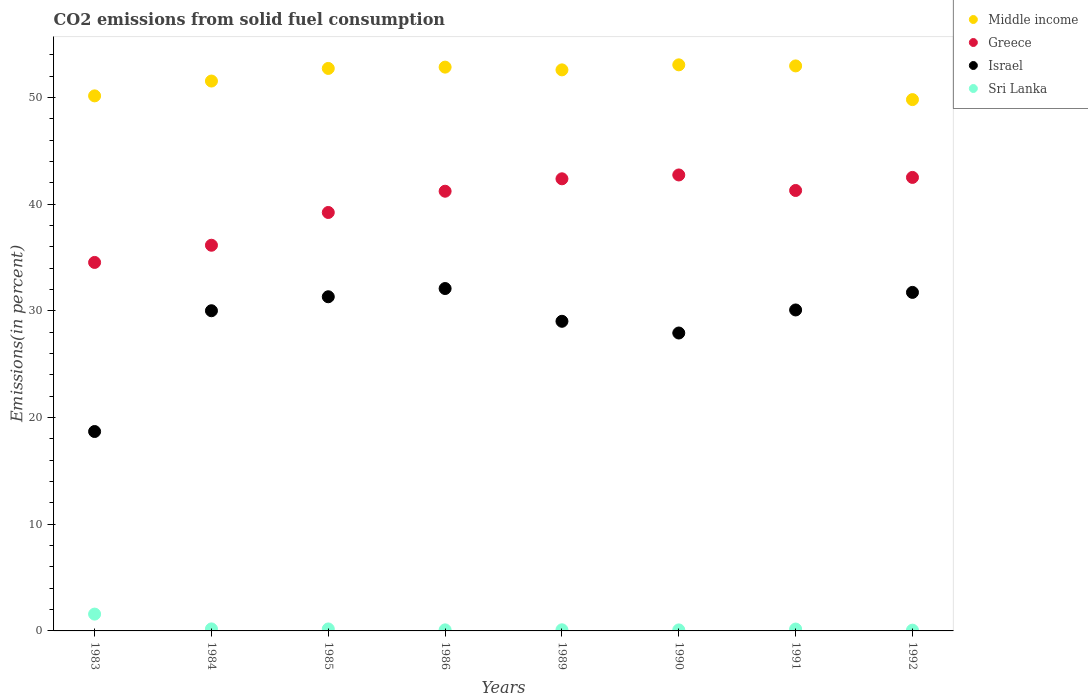How many different coloured dotlines are there?
Your answer should be very brief. 4. What is the total CO2 emitted in Sri Lanka in 1990?
Give a very brief answer. 0.09. Across all years, what is the maximum total CO2 emitted in Sri Lanka?
Ensure brevity in your answer.  1.58. Across all years, what is the minimum total CO2 emitted in Israel?
Provide a succinct answer. 18.69. What is the total total CO2 emitted in Greece in the graph?
Provide a succinct answer. 319.99. What is the difference between the total CO2 emitted in Sri Lanka in 1985 and that in 1990?
Your answer should be very brief. 0.09. What is the difference between the total CO2 emitted in Sri Lanka in 1986 and the total CO2 emitted in Middle income in 1990?
Your response must be concise. -52.95. What is the average total CO2 emitted in Middle income per year?
Keep it short and to the point. 51.95. In the year 1984, what is the difference between the total CO2 emitted in Sri Lanka and total CO2 emitted in Greece?
Provide a succinct answer. -35.96. What is the ratio of the total CO2 emitted in Sri Lanka in 1984 to that in 1991?
Keep it short and to the point. 1.08. Is the total CO2 emitted in Sri Lanka in 1984 less than that in 1990?
Offer a terse response. No. Is the difference between the total CO2 emitted in Sri Lanka in 1985 and 1992 greater than the difference between the total CO2 emitted in Greece in 1985 and 1992?
Provide a short and direct response. Yes. What is the difference between the highest and the second highest total CO2 emitted in Middle income?
Give a very brief answer. 0.1. What is the difference between the highest and the lowest total CO2 emitted in Israel?
Keep it short and to the point. 13.4. In how many years, is the total CO2 emitted in Middle income greater than the average total CO2 emitted in Middle income taken over all years?
Offer a terse response. 5. Is it the case that in every year, the sum of the total CO2 emitted in Israel and total CO2 emitted in Greece  is greater than the total CO2 emitted in Middle income?
Give a very brief answer. Yes. Does the total CO2 emitted in Sri Lanka monotonically increase over the years?
Provide a short and direct response. No. Is the total CO2 emitted in Middle income strictly greater than the total CO2 emitted in Greece over the years?
Provide a short and direct response. Yes. Is the total CO2 emitted in Israel strictly less than the total CO2 emitted in Greece over the years?
Provide a short and direct response. Yes. How many dotlines are there?
Make the answer very short. 4. How many years are there in the graph?
Give a very brief answer. 8. Are the values on the major ticks of Y-axis written in scientific E-notation?
Provide a short and direct response. No. Where does the legend appear in the graph?
Keep it short and to the point. Top right. How many legend labels are there?
Give a very brief answer. 4. What is the title of the graph?
Give a very brief answer. CO2 emissions from solid fuel consumption. What is the label or title of the X-axis?
Offer a very short reply. Years. What is the label or title of the Y-axis?
Your response must be concise. Emissions(in percent). What is the Emissions(in percent) in Middle income in 1983?
Your answer should be compact. 50.15. What is the Emissions(in percent) of Greece in 1983?
Provide a short and direct response. 34.53. What is the Emissions(in percent) in Israel in 1983?
Make the answer very short. 18.69. What is the Emissions(in percent) in Sri Lanka in 1983?
Provide a short and direct response. 1.58. What is the Emissions(in percent) in Middle income in 1984?
Provide a short and direct response. 51.53. What is the Emissions(in percent) of Greece in 1984?
Your answer should be very brief. 36.15. What is the Emissions(in percent) of Israel in 1984?
Your response must be concise. 30.01. What is the Emissions(in percent) in Sri Lanka in 1984?
Provide a succinct answer. 0.19. What is the Emissions(in percent) of Middle income in 1985?
Your answer should be very brief. 52.72. What is the Emissions(in percent) in Greece in 1985?
Keep it short and to the point. 39.22. What is the Emissions(in percent) of Israel in 1985?
Your response must be concise. 31.32. What is the Emissions(in percent) in Sri Lanka in 1985?
Make the answer very short. 0.19. What is the Emissions(in percent) of Middle income in 1986?
Offer a very short reply. 52.84. What is the Emissions(in percent) in Greece in 1986?
Provide a succinct answer. 41.21. What is the Emissions(in percent) in Israel in 1986?
Your answer should be very brief. 32.09. What is the Emissions(in percent) of Sri Lanka in 1986?
Your answer should be very brief. 0.1. What is the Emissions(in percent) in Middle income in 1989?
Keep it short and to the point. 52.58. What is the Emissions(in percent) of Greece in 1989?
Keep it short and to the point. 42.37. What is the Emissions(in percent) of Israel in 1989?
Keep it short and to the point. 29.02. What is the Emissions(in percent) in Sri Lanka in 1989?
Ensure brevity in your answer.  0.11. What is the Emissions(in percent) of Middle income in 1990?
Provide a short and direct response. 53.05. What is the Emissions(in percent) in Greece in 1990?
Offer a terse response. 42.73. What is the Emissions(in percent) of Israel in 1990?
Give a very brief answer. 27.92. What is the Emissions(in percent) of Sri Lanka in 1990?
Ensure brevity in your answer.  0.09. What is the Emissions(in percent) in Middle income in 1991?
Keep it short and to the point. 52.95. What is the Emissions(in percent) in Greece in 1991?
Keep it short and to the point. 41.28. What is the Emissions(in percent) of Israel in 1991?
Keep it short and to the point. 30.08. What is the Emissions(in percent) of Sri Lanka in 1991?
Ensure brevity in your answer.  0.18. What is the Emissions(in percent) in Middle income in 1992?
Make the answer very short. 49.8. What is the Emissions(in percent) of Greece in 1992?
Make the answer very short. 42.5. What is the Emissions(in percent) of Israel in 1992?
Provide a short and direct response. 31.73. What is the Emissions(in percent) of Sri Lanka in 1992?
Offer a terse response. 0.07. Across all years, what is the maximum Emissions(in percent) in Middle income?
Give a very brief answer. 53.05. Across all years, what is the maximum Emissions(in percent) of Greece?
Provide a short and direct response. 42.73. Across all years, what is the maximum Emissions(in percent) of Israel?
Offer a terse response. 32.09. Across all years, what is the maximum Emissions(in percent) in Sri Lanka?
Keep it short and to the point. 1.58. Across all years, what is the minimum Emissions(in percent) of Middle income?
Make the answer very short. 49.8. Across all years, what is the minimum Emissions(in percent) in Greece?
Your answer should be very brief. 34.53. Across all years, what is the minimum Emissions(in percent) in Israel?
Make the answer very short. 18.69. Across all years, what is the minimum Emissions(in percent) of Sri Lanka?
Offer a terse response. 0.07. What is the total Emissions(in percent) in Middle income in the graph?
Make the answer very short. 415.62. What is the total Emissions(in percent) of Greece in the graph?
Provide a short and direct response. 319.99. What is the total Emissions(in percent) in Israel in the graph?
Offer a terse response. 230.85. What is the total Emissions(in percent) in Sri Lanka in the graph?
Keep it short and to the point. 2.5. What is the difference between the Emissions(in percent) in Middle income in 1983 and that in 1984?
Offer a very short reply. -1.39. What is the difference between the Emissions(in percent) of Greece in 1983 and that in 1984?
Your answer should be very brief. -1.61. What is the difference between the Emissions(in percent) in Israel in 1983 and that in 1984?
Offer a terse response. -11.32. What is the difference between the Emissions(in percent) of Sri Lanka in 1983 and that in 1984?
Provide a succinct answer. 1.39. What is the difference between the Emissions(in percent) in Middle income in 1983 and that in 1985?
Ensure brevity in your answer.  -2.57. What is the difference between the Emissions(in percent) of Greece in 1983 and that in 1985?
Provide a short and direct response. -4.68. What is the difference between the Emissions(in percent) of Israel in 1983 and that in 1985?
Your answer should be compact. -12.63. What is the difference between the Emissions(in percent) of Sri Lanka in 1983 and that in 1985?
Provide a short and direct response. 1.39. What is the difference between the Emissions(in percent) of Middle income in 1983 and that in 1986?
Give a very brief answer. -2.69. What is the difference between the Emissions(in percent) of Greece in 1983 and that in 1986?
Keep it short and to the point. -6.67. What is the difference between the Emissions(in percent) in Israel in 1983 and that in 1986?
Provide a short and direct response. -13.4. What is the difference between the Emissions(in percent) of Sri Lanka in 1983 and that in 1986?
Your answer should be compact. 1.48. What is the difference between the Emissions(in percent) of Middle income in 1983 and that in 1989?
Keep it short and to the point. -2.44. What is the difference between the Emissions(in percent) of Greece in 1983 and that in 1989?
Offer a very short reply. -7.84. What is the difference between the Emissions(in percent) in Israel in 1983 and that in 1989?
Offer a terse response. -10.33. What is the difference between the Emissions(in percent) in Sri Lanka in 1983 and that in 1989?
Give a very brief answer. 1.47. What is the difference between the Emissions(in percent) of Middle income in 1983 and that in 1990?
Your response must be concise. -2.91. What is the difference between the Emissions(in percent) in Greece in 1983 and that in 1990?
Provide a succinct answer. -8.2. What is the difference between the Emissions(in percent) in Israel in 1983 and that in 1990?
Keep it short and to the point. -9.23. What is the difference between the Emissions(in percent) of Sri Lanka in 1983 and that in 1990?
Provide a short and direct response. 1.48. What is the difference between the Emissions(in percent) of Middle income in 1983 and that in 1991?
Offer a very short reply. -2.81. What is the difference between the Emissions(in percent) of Greece in 1983 and that in 1991?
Your response must be concise. -6.74. What is the difference between the Emissions(in percent) of Israel in 1983 and that in 1991?
Give a very brief answer. -11.39. What is the difference between the Emissions(in percent) in Sri Lanka in 1983 and that in 1991?
Keep it short and to the point. 1.4. What is the difference between the Emissions(in percent) in Middle income in 1983 and that in 1992?
Provide a succinct answer. 0.35. What is the difference between the Emissions(in percent) of Greece in 1983 and that in 1992?
Offer a terse response. -7.97. What is the difference between the Emissions(in percent) of Israel in 1983 and that in 1992?
Your response must be concise. -13.04. What is the difference between the Emissions(in percent) of Sri Lanka in 1983 and that in 1992?
Your answer should be compact. 1.51. What is the difference between the Emissions(in percent) of Middle income in 1984 and that in 1985?
Your answer should be very brief. -1.18. What is the difference between the Emissions(in percent) of Greece in 1984 and that in 1985?
Offer a very short reply. -3.07. What is the difference between the Emissions(in percent) in Israel in 1984 and that in 1985?
Give a very brief answer. -1.31. What is the difference between the Emissions(in percent) of Sri Lanka in 1984 and that in 1985?
Offer a very short reply. 0. What is the difference between the Emissions(in percent) of Middle income in 1984 and that in 1986?
Your answer should be compact. -1.3. What is the difference between the Emissions(in percent) in Greece in 1984 and that in 1986?
Offer a very short reply. -5.06. What is the difference between the Emissions(in percent) in Israel in 1984 and that in 1986?
Provide a succinct answer. -2.08. What is the difference between the Emissions(in percent) of Sri Lanka in 1984 and that in 1986?
Your answer should be compact. 0.09. What is the difference between the Emissions(in percent) in Middle income in 1984 and that in 1989?
Your answer should be very brief. -1.05. What is the difference between the Emissions(in percent) of Greece in 1984 and that in 1989?
Give a very brief answer. -6.23. What is the difference between the Emissions(in percent) in Israel in 1984 and that in 1989?
Provide a succinct answer. 0.99. What is the difference between the Emissions(in percent) of Sri Lanka in 1984 and that in 1989?
Make the answer very short. 0.08. What is the difference between the Emissions(in percent) in Middle income in 1984 and that in 1990?
Give a very brief answer. -1.52. What is the difference between the Emissions(in percent) of Greece in 1984 and that in 1990?
Provide a short and direct response. -6.59. What is the difference between the Emissions(in percent) in Israel in 1984 and that in 1990?
Your response must be concise. 2.09. What is the difference between the Emissions(in percent) in Sri Lanka in 1984 and that in 1990?
Ensure brevity in your answer.  0.09. What is the difference between the Emissions(in percent) in Middle income in 1984 and that in 1991?
Keep it short and to the point. -1.42. What is the difference between the Emissions(in percent) in Greece in 1984 and that in 1991?
Keep it short and to the point. -5.13. What is the difference between the Emissions(in percent) in Israel in 1984 and that in 1991?
Make the answer very short. -0.07. What is the difference between the Emissions(in percent) in Sri Lanka in 1984 and that in 1991?
Offer a terse response. 0.01. What is the difference between the Emissions(in percent) of Middle income in 1984 and that in 1992?
Your answer should be very brief. 1.74. What is the difference between the Emissions(in percent) in Greece in 1984 and that in 1992?
Keep it short and to the point. -6.36. What is the difference between the Emissions(in percent) of Israel in 1984 and that in 1992?
Ensure brevity in your answer.  -1.72. What is the difference between the Emissions(in percent) in Sri Lanka in 1984 and that in 1992?
Offer a very short reply. 0.12. What is the difference between the Emissions(in percent) of Middle income in 1985 and that in 1986?
Offer a terse response. -0.12. What is the difference between the Emissions(in percent) of Greece in 1985 and that in 1986?
Ensure brevity in your answer.  -1.99. What is the difference between the Emissions(in percent) of Israel in 1985 and that in 1986?
Give a very brief answer. -0.77. What is the difference between the Emissions(in percent) in Sri Lanka in 1985 and that in 1986?
Make the answer very short. 0.09. What is the difference between the Emissions(in percent) of Middle income in 1985 and that in 1989?
Give a very brief answer. 0.14. What is the difference between the Emissions(in percent) of Greece in 1985 and that in 1989?
Make the answer very short. -3.16. What is the difference between the Emissions(in percent) of Israel in 1985 and that in 1989?
Provide a succinct answer. 2.3. What is the difference between the Emissions(in percent) of Sri Lanka in 1985 and that in 1989?
Offer a terse response. 0.08. What is the difference between the Emissions(in percent) of Middle income in 1985 and that in 1990?
Keep it short and to the point. -0.34. What is the difference between the Emissions(in percent) of Greece in 1985 and that in 1990?
Make the answer very short. -3.52. What is the difference between the Emissions(in percent) in Israel in 1985 and that in 1990?
Offer a terse response. 3.4. What is the difference between the Emissions(in percent) of Sri Lanka in 1985 and that in 1990?
Give a very brief answer. 0.09. What is the difference between the Emissions(in percent) in Middle income in 1985 and that in 1991?
Your answer should be very brief. -0.24. What is the difference between the Emissions(in percent) in Greece in 1985 and that in 1991?
Your answer should be compact. -2.06. What is the difference between the Emissions(in percent) in Israel in 1985 and that in 1991?
Your answer should be very brief. 1.24. What is the difference between the Emissions(in percent) in Sri Lanka in 1985 and that in 1991?
Give a very brief answer. 0.01. What is the difference between the Emissions(in percent) in Middle income in 1985 and that in 1992?
Provide a succinct answer. 2.92. What is the difference between the Emissions(in percent) of Greece in 1985 and that in 1992?
Keep it short and to the point. -3.29. What is the difference between the Emissions(in percent) of Israel in 1985 and that in 1992?
Your answer should be very brief. -0.41. What is the difference between the Emissions(in percent) of Sri Lanka in 1985 and that in 1992?
Offer a terse response. 0.11. What is the difference between the Emissions(in percent) of Middle income in 1986 and that in 1989?
Provide a succinct answer. 0.26. What is the difference between the Emissions(in percent) in Greece in 1986 and that in 1989?
Ensure brevity in your answer.  -1.16. What is the difference between the Emissions(in percent) in Israel in 1986 and that in 1989?
Give a very brief answer. 3.07. What is the difference between the Emissions(in percent) of Sri Lanka in 1986 and that in 1989?
Your answer should be compact. -0.01. What is the difference between the Emissions(in percent) in Middle income in 1986 and that in 1990?
Provide a short and direct response. -0.21. What is the difference between the Emissions(in percent) of Greece in 1986 and that in 1990?
Provide a succinct answer. -1.52. What is the difference between the Emissions(in percent) in Israel in 1986 and that in 1990?
Keep it short and to the point. 4.17. What is the difference between the Emissions(in percent) in Sri Lanka in 1986 and that in 1990?
Keep it short and to the point. 0. What is the difference between the Emissions(in percent) in Middle income in 1986 and that in 1991?
Offer a terse response. -0.11. What is the difference between the Emissions(in percent) of Greece in 1986 and that in 1991?
Provide a succinct answer. -0.07. What is the difference between the Emissions(in percent) of Israel in 1986 and that in 1991?
Ensure brevity in your answer.  2.01. What is the difference between the Emissions(in percent) in Sri Lanka in 1986 and that in 1991?
Your response must be concise. -0.08. What is the difference between the Emissions(in percent) of Middle income in 1986 and that in 1992?
Provide a succinct answer. 3.04. What is the difference between the Emissions(in percent) in Greece in 1986 and that in 1992?
Your answer should be compact. -1.29. What is the difference between the Emissions(in percent) of Israel in 1986 and that in 1992?
Provide a succinct answer. 0.36. What is the difference between the Emissions(in percent) of Sri Lanka in 1986 and that in 1992?
Offer a very short reply. 0.03. What is the difference between the Emissions(in percent) in Middle income in 1989 and that in 1990?
Provide a succinct answer. -0.47. What is the difference between the Emissions(in percent) of Greece in 1989 and that in 1990?
Offer a terse response. -0.36. What is the difference between the Emissions(in percent) in Israel in 1989 and that in 1990?
Your response must be concise. 1.1. What is the difference between the Emissions(in percent) in Sri Lanka in 1989 and that in 1990?
Offer a terse response. 0.01. What is the difference between the Emissions(in percent) of Middle income in 1989 and that in 1991?
Your response must be concise. -0.37. What is the difference between the Emissions(in percent) of Greece in 1989 and that in 1991?
Your answer should be compact. 1.09. What is the difference between the Emissions(in percent) of Israel in 1989 and that in 1991?
Give a very brief answer. -1.06. What is the difference between the Emissions(in percent) of Sri Lanka in 1989 and that in 1991?
Your answer should be very brief. -0.07. What is the difference between the Emissions(in percent) of Middle income in 1989 and that in 1992?
Offer a terse response. 2.79. What is the difference between the Emissions(in percent) in Greece in 1989 and that in 1992?
Provide a succinct answer. -0.13. What is the difference between the Emissions(in percent) in Israel in 1989 and that in 1992?
Provide a short and direct response. -2.71. What is the difference between the Emissions(in percent) of Sri Lanka in 1989 and that in 1992?
Offer a very short reply. 0.03. What is the difference between the Emissions(in percent) in Middle income in 1990 and that in 1991?
Provide a short and direct response. 0.1. What is the difference between the Emissions(in percent) in Greece in 1990 and that in 1991?
Offer a very short reply. 1.45. What is the difference between the Emissions(in percent) in Israel in 1990 and that in 1991?
Your response must be concise. -2.16. What is the difference between the Emissions(in percent) of Sri Lanka in 1990 and that in 1991?
Offer a very short reply. -0.08. What is the difference between the Emissions(in percent) in Middle income in 1990 and that in 1992?
Provide a succinct answer. 3.26. What is the difference between the Emissions(in percent) in Greece in 1990 and that in 1992?
Provide a short and direct response. 0.23. What is the difference between the Emissions(in percent) of Israel in 1990 and that in 1992?
Provide a succinct answer. -3.81. What is the difference between the Emissions(in percent) in Sri Lanka in 1990 and that in 1992?
Offer a terse response. 0.02. What is the difference between the Emissions(in percent) in Middle income in 1991 and that in 1992?
Keep it short and to the point. 3.16. What is the difference between the Emissions(in percent) of Greece in 1991 and that in 1992?
Provide a short and direct response. -1.22. What is the difference between the Emissions(in percent) of Israel in 1991 and that in 1992?
Give a very brief answer. -1.65. What is the difference between the Emissions(in percent) of Sri Lanka in 1991 and that in 1992?
Offer a terse response. 0.1. What is the difference between the Emissions(in percent) of Middle income in 1983 and the Emissions(in percent) of Greece in 1984?
Give a very brief answer. 14. What is the difference between the Emissions(in percent) in Middle income in 1983 and the Emissions(in percent) in Israel in 1984?
Your response must be concise. 20.14. What is the difference between the Emissions(in percent) in Middle income in 1983 and the Emissions(in percent) in Sri Lanka in 1984?
Your response must be concise. 49.96. What is the difference between the Emissions(in percent) of Greece in 1983 and the Emissions(in percent) of Israel in 1984?
Offer a terse response. 4.53. What is the difference between the Emissions(in percent) of Greece in 1983 and the Emissions(in percent) of Sri Lanka in 1984?
Your response must be concise. 34.35. What is the difference between the Emissions(in percent) in Israel in 1983 and the Emissions(in percent) in Sri Lanka in 1984?
Your response must be concise. 18.5. What is the difference between the Emissions(in percent) in Middle income in 1983 and the Emissions(in percent) in Greece in 1985?
Provide a succinct answer. 10.93. What is the difference between the Emissions(in percent) in Middle income in 1983 and the Emissions(in percent) in Israel in 1985?
Make the answer very short. 18.83. What is the difference between the Emissions(in percent) of Middle income in 1983 and the Emissions(in percent) of Sri Lanka in 1985?
Provide a succinct answer. 49.96. What is the difference between the Emissions(in percent) in Greece in 1983 and the Emissions(in percent) in Israel in 1985?
Offer a very short reply. 3.22. What is the difference between the Emissions(in percent) of Greece in 1983 and the Emissions(in percent) of Sri Lanka in 1985?
Provide a succinct answer. 34.35. What is the difference between the Emissions(in percent) in Israel in 1983 and the Emissions(in percent) in Sri Lanka in 1985?
Your answer should be very brief. 18.5. What is the difference between the Emissions(in percent) of Middle income in 1983 and the Emissions(in percent) of Greece in 1986?
Keep it short and to the point. 8.94. What is the difference between the Emissions(in percent) in Middle income in 1983 and the Emissions(in percent) in Israel in 1986?
Your answer should be very brief. 18.06. What is the difference between the Emissions(in percent) in Middle income in 1983 and the Emissions(in percent) in Sri Lanka in 1986?
Provide a succinct answer. 50.05. What is the difference between the Emissions(in percent) in Greece in 1983 and the Emissions(in percent) in Israel in 1986?
Your answer should be compact. 2.45. What is the difference between the Emissions(in percent) of Greece in 1983 and the Emissions(in percent) of Sri Lanka in 1986?
Your response must be concise. 34.44. What is the difference between the Emissions(in percent) of Israel in 1983 and the Emissions(in percent) of Sri Lanka in 1986?
Give a very brief answer. 18.59. What is the difference between the Emissions(in percent) in Middle income in 1983 and the Emissions(in percent) in Greece in 1989?
Provide a short and direct response. 7.77. What is the difference between the Emissions(in percent) of Middle income in 1983 and the Emissions(in percent) of Israel in 1989?
Ensure brevity in your answer.  21.13. What is the difference between the Emissions(in percent) in Middle income in 1983 and the Emissions(in percent) in Sri Lanka in 1989?
Provide a succinct answer. 50.04. What is the difference between the Emissions(in percent) of Greece in 1983 and the Emissions(in percent) of Israel in 1989?
Your answer should be very brief. 5.52. What is the difference between the Emissions(in percent) of Greece in 1983 and the Emissions(in percent) of Sri Lanka in 1989?
Your answer should be very brief. 34.43. What is the difference between the Emissions(in percent) of Israel in 1983 and the Emissions(in percent) of Sri Lanka in 1989?
Ensure brevity in your answer.  18.58. What is the difference between the Emissions(in percent) in Middle income in 1983 and the Emissions(in percent) in Greece in 1990?
Offer a very short reply. 7.41. What is the difference between the Emissions(in percent) in Middle income in 1983 and the Emissions(in percent) in Israel in 1990?
Your answer should be very brief. 22.22. What is the difference between the Emissions(in percent) of Middle income in 1983 and the Emissions(in percent) of Sri Lanka in 1990?
Ensure brevity in your answer.  50.05. What is the difference between the Emissions(in percent) in Greece in 1983 and the Emissions(in percent) in Israel in 1990?
Keep it short and to the point. 6.61. What is the difference between the Emissions(in percent) of Greece in 1983 and the Emissions(in percent) of Sri Lanka in 1990?
Ensure brevity in your answer.  34.44. What is the difference between the Emissions(in percent) in Israel in 1983 and the Emissions(in percent) in Sri Lanka in 1990?
Keep it short and to the point. 18.59. What is the difference between the Emissions(in percent) of Middle income in 1983 and the Emissions(in percent) of Greece in 1991?
Provide a short and direct response. 8.87. What is the difference between the Emissions(in percent) of Middle income in 1983 and the Emissions(in percent) of Israel in 1991?
Your answer should be very brief. 20.06. What is the difference between the Emissions(in percent) of Middle income in 1983 and the Emissions(in percent) of Sri Lanka in 1991?
Keep it short and to the point. 49.97. What is the difference between the Emissions(in percent) in Greece in 1983 and the Emissions(in percent) in Israel in 1991?
Ensure brevity in your answer.  4.45. What is the difference between the Emissions(in percent) in Greece in 1983 and the Emissions(in percent) in Sri Lanka in 1991?
Your answer should be very brief. 34.36. What is the difference between the Emissions(in percent) of Israel in 1983 and the Emissions(in percent) of Sri Lanka in 1991?
Offer a very short reply. 18.51. What is the difference between the Emissions(in percent) of Middle income in 1983 and the Emissions(in percent) of Greece in 1992?
Provide a succinct answer. 7.64. What is the difference between the Emissions(in percent) of Middle income in 1983 and the Emissions(in percent) of Israel in 1992?
Offer a very short reply. 18.42. What is the difference between the Emissions(in percent) in Middle income in 1983 and the Emissions(in percent) in Sri Lanka in 1992?
Provide a succinct answer. 50.07. What is the difference between the Emissions(in percent) of Greece in 1983 and the Emissions(in percent) of Israel in 1992?
Keep it short and to the point. 2.81. What is the difference between the Emissions(in percent) in Greece in 1983 and the Emissions(in percent) in Sri Lanka in 1992?
Offer a terse response. 34.46. What is the difference between the Emissions(in percent) of Israel in 1983 and the Emissions(in percent) of Sri Lanka in 1992?
Your answer should be compact. 18.62. What is the difference between the Emissions(in percent) in Middle income in 1984 and the Emissions(in percent) in Greece in 1985?
Your response must be concise. 12.32. What is the difference between the Emissions(in percent) in Middle income in 1984 and the Emissions(in percent) in Israel in 1985?
Offer a very short reply. 20.22. What is the difference between the Emissions(in percent) of Middle income in 1984 and the Emissions(in percent) of Sri Lanka in 1985?
Ensure brevity in your answer.  51.35. What is the difference between the Emissions(in percent) in Greece in 1984 and the Emissions(in percent) in Israel in 1985?
Your answer should be compact. 4.83. What is the difference between the Emissions(in percent) in Greece in 1984 and the Emissions(in percent) in Sri Lanka in 1985?
Ensure brevity in your answer.  35.96. What is the difference between the Emissions(in percent) of Israel in 1984 and the Emissions(in percent) of Sri Lanka in 1985?
Keep it short and to the point. 29.82. What is the difference between the Emissions(in percent) of Middle income in 1984 and the Emissions(in percent) of Greece in 1986?
Make the answer very short. 10.33. What is the difference between the Emissions(in percent) in Middle income in 1984 and the Emissions(in percent) in Israel in 1986?
Your response must be concise. 19.45. What is the difference between the Emissions(in percent) of Middle income in 1984 and the Emissions(in percent) of Sri Lanka in 1986?
Your answer should be compact. 51.44. What is the difference between the Emissions(in percent) in Greece in 1984 and the Emissions(in percent) in Israel in 1986?
Provide a succinct answer. 4.06. What is the difference between the Emissions(in percent) of Greece in 1984 and the Emissions(in percent) of Sri Lanka in 1986?
Keep it short and to the point. 36.05. What is the difference between the Emissions(in percent) in Israel in 1984 and the Emissions(in percent) in Sri Lanka in 1986?
Offer a very short reply. 29.91. What is the difference between the Emissions(in percent) of Middle income in 1984 and the Emissions(in percent) of Greece in 1989?
Your response must be concise. 9.16. What is the difference between the Emissions(in percent) in Middle income in 1984 and the Emissions(in percent) in Israel in 1989?
Offer a terse response. 22.52. What is the difference between the Emissions(in percent) of Middle income in 1984 and the Emissions(in percent) of Sri Lanka in 1989?
Your response must be concise. 51.43. What is the difference between the Emissions(in percent) of Greece in 1984 and the Emissions(in percent) of Israel in 1989?
Give a very brief answer. 7.13. What is the difference between the Emissions(in percent) in Greece in 1984 and the Emissions(in percent) in Sri Lanka in 1989?
Your answer should be compact. 36.04. What is the difference between the Emissions(in percent) in Israel in 1984 and the Emissions(in percent) in Sri Lanka in 1989?
Make the answer very short. 29.9. What is the difference between the Emissions(in percent) in Middle income in 1984 and the Emissions(in percent) in Greece in 1990?
Offer a very short reply. 8.8. What is the difference between the Emissions(in percent) in Middle income in 1984 and the Emissions(in percent) in Israel in 1990?
Ensure brevity in your answer.  23.61. What is the difference between the Emissions(in percent) of Middle income in 1984 and the Emissions(in percent) of Sri Lanka in 1990?
Offer a terse response. 51.44. What is the difference between the Emissions(in percent) in Greece in 1984 and the Emissions(in percent) in Israel in 1990?
Give a very brief answer. 8.23. What is the difference between the Emissions(in percent) of Greece in 1984 and the Emissions(in percent) of Sri Lanka in 1990?
Offer a terse response. 36.05. What is the difference between the Emissions(in percent) of Israel in 1984 and the Emissions(in percent) of Sri Lanka in 1990?
Keep it short and to the point. 29.91. What is the difference between the Emissions(in percent) in Middle income in 1984 and the Emissions(in percent) in Greece in 1991?
Provide a succinct answer. 10.26. What is the difference between the Emissions(in percent) in Middle income in 1984 and the Emissions(in percent) in Israel in 1991?
Offer a terse response. 21.45. What is the difference between the Emissions(in percent) of Middle income in 1984 and the Emissions(in percent) of Sri Lanka in 1991?
Offer a terse response. 51.36. What is the difference between the Emissions(in percent) in Greece in 1984 and the Emissions(in percent) in Israel in 1991?
Your answer should be very brief. 6.07. What is the difference between the Emissions(in percent) in Greece in 1984 and the Emissions(in percent) in Sri Lanka in 1991?
Give a very brief answer. 35.97. What is the difference between the Emissions(in percent) in Israel in 1984 and the Emissions(in percent) in Sri Lanka in 1991?
Ensure brevity in your answer.  29.83. What is the difference between the Emissions(in percent) of Middle income in 1984 and the Emissions(in percent) of Greece in 1992?
Your answer should be compact. 9.03. What is the difference between the Emissions(in percent) in Middle income in 1984 and the Emissions(in percent) in Israel in 1992?
Make the answer very short. 19.81. What is the difference between the Emissions(in percent) in Middle income in 1984 and the Emissions(in percent) in Sri Lanka in 1992?
Ensure brevity in your answer.  51.46. What is the difference between the Emissions(in percent) of Greece in 1984 and the Emissions(in percent) of Israel in 1992?
Ensure brevity in your answer.  4.42. What is the difference between the Emissions(in percent) in Greece in 1984 and the Emissions(in percent) in Sri Lanka in 1992?
Your answer should be compact. 36.08. What is the difference between the Emissions(in percent) of Israel in 1984 and the Emissions(in percent) of Sri Lanka in 1992?
Make the answer very short. 29.94. What is the difference between the Emissions(in percent) in Middle income in 1985 and the Emissions(in percent) in Greece in 1986?
Your response must be concise. 11.51. What is the difference between the Emissions(in percent) of Middle income in 1985 and the Emissions(in percent) of Israel in 1986?
Your answer should be compact. 20.63. What is the difference between the Emissions(in percent) in Middle income in 1985 and the Emissions(in percent) in Sri Lanka in 1986?
Keep it short and to the point. 52.62. What is the difference between the Emissions(in percent) in Greece in 1985 and the Emissions(in percent) in Israel in 1986?
Your answer should be very brief. 7.13. What is the difference between the Emissions(in percent) in Greece in 1985 and the Emissions(in percent) in Sri Lanka in 1986?
Provide a short and direct response. 39.12. What is the difference between the Emissions(in percent) of Israel in 1985 and the Emissions(in percent) of Sri Lanka in 1986?
Offer a terse response. 31.22. What is the difference between the Emissions(in percent) in Middle income in 1985 and the Emissions(in percent) in Greece in 1989?
Make the answer very short. 10.34. What is the difference between the Emissions(in percent) of Middle income in 1985 and the Emissions(in percent) of Israel in 1989?
Make the answer very short. 23.7. What is the difference between the Emissions(in percent) of Middle income in 1985 and the Emissions(in percent) of Sri Lanka in 1989?
Ensure brevity in your answer.  52.61. What is the difference between the Emissions(in percent) of Greece in 1985 and the Emissions(in percent) of Israel in 1989?
Give a very brief answer. 10.2. What is the difference between the Emissions(in percent) of Greece in 1985 and the Emissions(in percent) of Sri Lanka in 1989?
Provide a succinct answer. 39.11. What is the difference between the Emissions(in percent) of Israel in 1985 and the Emissions(in percent) of Sri Lanka in 1989?
Provide a short and direct response. 31.21. What is the difference between the Emissions(in percent) in Middle income in 1985 and the Emissions(in percent) in Greece in 1990?
Your answer should be very brief. 9.98. What is the difference between the Emissions(in percent) of Middle income in 1985 and the Emissions(in percent) of Israel in 1990?
Provide a short and direct response. 24.8. What is the difference between the Emissions(in percent) in Middle income in 1985 and the Emissions(in percent) in Sri Lanka in 1990?
Provide a short and direct response. 52.62. What is the difference between the Emissions(in percent) in Greece in 1985 and the Emissions(in percent) in Israel in 1990?
Your response must be concise. 11.3. What is the difference between the Emissions(in percent) of Greece in 1985 and the Emissions(in percent) of Sri Lanka in 1990?
Keep it short and to the point. 39.12. What is the difference between the Emissions(in percent) of Israel in 1985 and the Emissions(in percent) of Sri Lanka in 1990?
Keep it short and to the point. 31.22. What is the difference between the Emissions(in percent) of Middle income in 1985 and the Emissions(in percent) of Greece in 1991?
Ensure brevity in your answer.  11.44. What is the difference between the Emissions(in percent) of Middle income in 1985 and the Emissions(in percent) of Israel in 1991?
Give a very brief answer. 22.64. What is the difference between the Emissions(in percent) of Middle income in 1985 and the Emissions(in percent) of Sri Lanka in 1991?
Your answer should be very brief. 52.54. What is the difference between the Emissions(in percent) of Greece in 1985 and the Emissions(in percent) of Israel in 1991?
Provide a short and direct response. 9.14. What is the difference between the Emissions(in percent) of Greece in 1985 and the Emissions(in percent) of Sri Lanka in 1991?
Make the answer very short. 39.04. What is the difference between the Emissions(in percent) in Israel in 1985 and the Emissions(in percent) in Sri Lanka in 1991?
Keep it short and to the point. 31.14. What is the difference between the Emissions(in percent) of Middle income in 1985 and the Emissions(in percent) of Greece in 1992?
Your response must be concise. 10.21. What is the difference between the Emissions(in percent) in Middle income in 1985 and the Emissions(in percent) in Israel in 1992?
Make the answer very short. 20.99. What is the difference between the Emissions(in percent) in Middle income in 1985 and the Emissions(in percent) in Sri Lanka in 1992?
Your response must be concise. 52.65. What is the difference between the Emissions(in percent) of Greece in 1985 and the Emissions(in percent) of Israel in 1992?
Provide a short and direct response. 7.49. What is the difference between the Emissions(in percent) of Greece in 1985 and the Emissions(in percent) of Sri Lanka in 1992?
Offer a terse response. 39.15. What is the difference between the Emissions(in percent) in Israel in 1985 and the Emissions(in percent) in Sri Lanka in 1992?
Make the answer very short. 31.25. What is the difference between the Emissions(in percent) in Middle income in 1986 and the Emissions(in percent) in Greece in 1989?
Make the answer very short. 10.47. What is the difference between the Emissions(in percent) in Middle income in 1986 and the Emissions(in percent) in Israel in 1989?
Keep it short and to the point. 23.82. What is the difference between the Emissions(in percent) in Middle income in 1986 and the Emissions(in percent) in Sri Lanka in 1989?
Provide a short and direct response. 52.73. What is the difference between the Emissions(in percent) in Greece in 1986 and the Emissions(in percent) in Israel in 1989?
Make the answer very short. 12.19. What is the difference between the Emissions(in percent) of Greece in 1986 and the Emissions(in percent) of Sri Lanka in 1989?
Your answer should be very brief. 41.1. What is the difference between the Emissions(in percent) of Israel in 1986 and the Emissions(in percent) of Sri Lanka in 1989?
Keep it short and to the point. 31.98. What is the difference between the Emissions(in percent) of Middle income in 1986 and the Emissions(in percent) of Greece in 1990?
Your answer should be compact. 10.11. What is the difference between the Emissions(in percent) of Middle income in 1986 and the Emissions(in percent) of Israel in 1990?
Offer a very short reply. 24.92. What is the difference between the Emissions(in percent) in Middle income in 1986 and the Emissions(in percent) in Sri Lanka in 1990?
Your response must be concise. 52.74. What is the difference between the Emissions(in percent) in Greece in 1986 and the Emissions(in percent) in Israel in 1990?
Your answer should be very brief. 13.29. What is the difference between the Emissions(in percent) of Greece in 1986 and the Emissions(in percent) of Sri Lanka in 1990?
Make the answer very short. 41.11. What is the difference between the Emissions(in percent) in Israel in 1986 and the Emissions(in percent) in Sri Lanka in 1990?
Your response must be concise. 31.99. What is the difference between the Emissions(in percent) of Middle income in 1986 and the Emissions(in percent) of Greece in 1991?
Make the answer very short. 11.56. What is the difference between the Emissions(in percent) of Middle income in 1986 and the Emissions(in percent) of Israel in 1991?
Provide a succinct answer. 22.76. What is the difference between the Emissions(in percent) in Middle income in 1986 and the Emissions(in percent) in Sri Lanka in 1991?
Offer a terse response. 52.66. What is the difference between the Emissions(in percent) of Greece in 1986 and the Emissions(in percent) of Israel in 1991?
Your answer should be compact. 11.13. What is the difference between the Emissions(in percent) in Greece in 1986 and the Emissions(in percent) in Sri Lanka in 1991?
Make the answer very short. 41.03. What is the difference between the Emissions(in percent) of Israel in 1986 and the Emissions(in percent) of Sri Lanka in 1991?
Offer a terse response. 31.91. What is the difference between the Emissions(in percent) in Middle income in 1986 and the Emissions(in percent) in Greece in 1992?
Give a very brief answer. 10.34. What is the difference between the Emissions(in percent) of Middle income in 1986 and the Emissions(in percent) of Israel in 1992?
Make the answer very short. 21.11. What is the difference between the Emissions(in percent) in Middle income in 1986 and the Emissions(in percent) in Sri Lanka in 1992?
Your response must be concise. 52.77. What is the difference between the Emissions(in percent) of Greece in 1986 and the Emissions(in percent) of Israel in 1992?
Keep it short and to the point. 9.48. What is the difference between the Emissions(in percent) of Greece in 1986 and the Emissions(in percent) of Sri Lanka in 1992?
Offer a terse response. 41.14. What is the difference between the Emissions(in percent) of Israel in 1986 and the Emissions(in percent) of Sri Lanka in 1992?
Your response must be concise. 32.02. What is the difference between the Emissions(in percent) of Middle income in 1989 and the Emissions(in percent) of Greece in 1990?
Give a very brief answer. 9.85. What is the difference between the Emissions(in percent) in Middle income in 1989 and the Emissions(in percent) in Israel in 1990?
Ensure brevity in your answer.  24.66. What is the difference between the Emissions(in percent) of Middle income in 1989 and the Emissions(in percent) of Sri Lanka in 1990?
Keep it short and to the point. 52.49. What is the difference between the Emissions(in percent) of Greece in 1989 and the Emissions(in percent) of Israel in 1990?
Provide a short and direct response. 14.45. What is the difference between the Emissions(in percent) in Greece in 1989 and the Emissions(in percent) in Sri Lanka in 1990?
Your answer should be very brief. 42.28. What is the difference between the Emissions(in percent) in Israel in 1989 and the Emissions(in percent) in Sri Lanka in 1990?
Your answer should be compact. 28.92. What is the difference between the Emissions(in percent) in Middle income in 1989 and the Emissions(in percent) in Greece in 1991?
Your response must be concise. 11.3. What is the difference between the Emissions(in percent) in Middle income in 1989 and the Emissions(in percent) in Israel in 1991?
Give a very brief answer. 22.5. What is the difference between the Emissions(in percent) in Middle income in 1989 and the Emissions(in percent) in Sri Lanka in 1991?
Provide a succinct answer. 52.41. What is the difference between the Emissions(in percent) in Greece in 1989 and the Emissions(in percent) in Israel in 1991?
Your answer should be very brief. 12.29. What is the difference between the Emissions(in percent) of Greece in 1989 and the Emissions(in percent) of Sri Lanka in 1991?
Ensure brevity in your answer.  42.2. What is the difference between the Emissions(in percent) of Israel in 1989 and the Emissions(in percent) of Sri Lanka in 1991?
Your answer should be very brief. 28.84. What is the difference between the Emissions(in percent) of Middle income in 1989 and the Emissions(in percent) of Greece in 1992?
Offer a very short reply. 10.08. What is the difference between the Emissions(in percent) in Middle income in 1989 and the Emissions(in percent) in Israel in 1992?
Keep it short and to the point. 20.86. What is the difference between the Emissions(in percent) of Middle income in 1989 and the Emissions(in percent) of Sri Lanka in 1992?
Make the answer very short. 52.51. What is the difference between the Emissions(in percent) of Greece in 1989 and the Emissions(in percent) of Israel in 1992?
Provide a succinct answer. 10.65. What is the difference between the Emissions(in percent) of Greece in 1989 and the Emissions(in percent) of Sri Lanka in 1992?
Your response must be concise. 42.3. What is the difference between the Emissions(in percent) of Israel in 1989 and the Emissions(in percent) of Sri Lanka in 1992?
Offer a terse response. 28.95. What is the difference between the Emissions(in percent) in Middle income in 1990 and the Emissions(in percent) in Greece in 1991?
Your response must be concise. 11.78. What is the difference between the Emissions(in percent) in Middle income in 1990 and the Emissions(in percent) in Israel in 1991?
Give a very brief answer. 22.97. What is the difference between the Emissions(in percent) in Middle income in 1990 and the Emissions(in percent) in Sri Lanka in 1991?
Make the answer very short. 52.88. What is the difference between the Emissions(in percent) of Greece in 1990 and the Emissions(in percent) of Israel in 1991?
Offer a terse response. 12.65. What is the difference between the Emissions(in percent) of Greece in 1990 and the Emissions(in percent) of Sri Lanka in 1991?
Give a very brief answer. 42.56. What is the difference between the Emissions(in percent) of Israel in 1990 and the Emissions(in percent) of Sri Lanka in 1991?
Ensure brevity in your answer.  27.74. What is the difference between the Emissions(in percent) of Middle income in 1990 and the Emissions(in percent) of Greece in 1992?
Your answer should be very brief. 10.55. What is the difference between the Emissions(in percent) in Middle income in 1990 and the Emissions(in percent) in Israel in 1992?
Provide a succinct answer. 21.33. What is the difference between the Emissions(in percent) of Middle income in 1990 and the Emissions(in percent) of Sri Lanka in 1992?
Ensure brevity in your answer.  52.98. What is the difference between the Emissions(in percent) in Greece in 1990 and the Emissions(in percent) in Israel in 1992?
Your answer should be very brief. 11.01. What is the difference between the Emissions(in percent) in Greece in 1990 and the Emissions(in percent) in Sri Lanka in 1992?
Provide a short and direct response. 42.66. What is the difference between the Emissions(in percent) in Israel in 1990 and the Emissions(in percent) in Sri Lanka in 1992?
Your response must be concise. 27.85. What is the difference between the Emissions(in percent) of Middle income in 1991 and the Emissions(in percent) of Greece in 1992?
Keep it short and to the point. 10.45. What is the difference between the Emissions(in percent) of Middle income in 1991 and the Emissions(in percent) of Israel in 1992?
Provide a short and direct response. 21.23. What is the difference between the Emissions(in percent) of Middle income in 1991 and the Emissions(in percent) of Sri Lanka in 1992?
Keep it short and to the point. 52.88. What is the difference between the Emissions(in percent) of Greece in 1991 and the Emissions(in percent) of Israel in 1992?
Provide a short and direct response. 9.55. What is the difference between the Emissions(in percent) of Greece in 1991 and the Emissions(in percent) of Sri Lanka in 1992?
Provide a short and direct response. 41.21. What is the difference between the Emissions(in percent) in Israel in 1991 and the Emissions(in percent) in Sri Lanka in 1992?
Keep it short and to the point. 30.01. What is the average Emissions(in percent) of Middle income per year?
Your response must be concise. 51.95. What is the average Emissions(in percent) in Greece per year?
Your answer should be compact. 40. What is the average Emissions(in percent) in Israel per year?
Provide a succinct answer. 28.86. What is the average Emissions(in percent) of Sri Lanka per year?
Your response must be concise. 0.31. In the year 1983, what is the difference between the Emissions(in percent) in Middle income and Emissions(in percent) in Greece?
Provide a succinct answer. 15.61. In the year 1983, what is the difference between the Emissions(in percent) of Middle income and Emissions(in percent) of Israel?
Provide a succinct answer. 31.46. In the year 1983, what is the difference between the Emissions(in percent) of Middle income and Emissions(in percent) of Sri Lanka?
Make the answer very short. 48.57. In the year 1983, what is the difference between the Emissions(in percent) in Greece and Emissions(in percent) in Israel?
Provide a short and direct response. 15.85. In the year 1983, what is the difference between the Emissions(in percent) of Greece and Emissions(in percent) of Sri Lanka?
Your answer should be compact. 32.96. In the year 1983, what is the difference between the Emissions(in percent) in Israel and Emissions(in percent) in Sri Lanka?
Provide a short and direct response. 17.11. In the year 1984, what is the difference between the Emissions(in percent) of Middle income and Emissions(in percent) of Greece?
Provide a short and direct response. 15.39. In the year 1984, what is the difference between the Emissions(in percent) of Middle income and Emissions(in percent) of Israel?
Ensure brevity in your answer.  21.53. In the year 1984, what is the difference between the Emissions(in percent) in Middle income and Emissions(in percent) in Sri Lanka?
Offer a very short reply. 51.35. In the year 1984, what is the difference between the Emissions(in percent) in Greece and Emissions(in percent) in Israel?
Your response must be concise. 6.14. In the year 1984, what is the difference between the Emissions(in percent) of Greece and Emissions(in percent) of Sri Lanka?
Provide a short and direct response. 35.96. In the year 1984, what is the difference between the Emissions(in percent) of Israel and Emissions(in percent) of Sri Lanka?
Make the answer very short. 29.82. In the year 1985, what is the difference between the Emissions(in percent) in Middle income and Emissions(in percent) in Greece?
Ensure brevity in your answer.  13.5. In the year 1985, what is the difference between the Emissions(in percent) in Middle income and Emissions(in percent) in Israel?
Your answer should be compact. 21.4. In the year 1985, what is the difference between the Emissions(in percent) of Middle income and Emissions(in percent) of Sri Lanka?
Keep it short and to the point. 52.53. In the year 1985, what is the difference between the Emissions(in percent) in Greece and Emissions(in percent) in Israel?
Keep it short and to the point. 7.9. In the year 1985, what is the difference between the Emissions(in percent) of Greece and Emissions(in percent) of Sri Lanka?
Your response must be concise. 39.03. In the year 1985, what is the difference between the Emissions(in percent) of Israel and Emissions(in percent) of Sri Lanka?
Offer a terse response. 31.13. In the year 1986, what is the difference between the Emissions(in percent) in Middle income and Emissions(in percent) in Greece?
Provide a short and direct response. 11.63. In the year 1986, what is the difference between the Emissions(in percent) in Middle income and Emissions(in percent) in Israel?
Offer a very short reply. 20.75. In the year 1986, what is the difference between the Emissions(in percent) in Middle income and Emissions(in percent) in Sri Lanka?
Your response must be concise. 52.74. In the year 1986, what is the difference between the Emissions(in percent) in Greece and Emissions(in percent) in Israel?
Offer a terse response. 9.12. In the year 1986, what is the difference between the Emissions(in percent) in Greece and Emissions(in percent) in Sri Lanka?
Offer a terse response. 41.11. In the year 1986, what is the difference between the Emissions(in percent) of Israel and Emissions(in percent) of Sri Lanka?
Your response must be concise. 31.99. In the year 1989, what is the difference between the Emissions(in percent) of Middle income and Emissions(in percent) of Greece?
Ensure brevity in your answer.  10.21. In the year 1989, what is the difference between the Emissions(in percent) in Middle income and Emissions(in percent) in Israel?
Give a very brief answer. 23.56. In the year 1989, what is the difference between the Emissions(in percent) in Middle income and Emissions(in percent) in Sri Lanka?
Your answer should be compact. 52.48. In the year 1989, what is the difference between the Emissions(in percent) of Greece and Emissions(in percent) of Israel?
Provide a succinct answer. 13.35. In the year 1989, what is the difference between the Emissions(in percent) of Greece and Emissions(in percent) of Sri Lanka?
Provide a short and direct response. 42.27. In the year 1989, what is the difference between the Emissions(in percent) in Israel and Emissions(in percent) in Sri Lanka?
Offer a terse response. 28.91. In the year 1990, what is the difference between the Emissions(in percent) of Middle income and Emissions(in percent) of Greece?
Provide a succinct answer. 10.32. In the year 1990, what is the difference between the Emissions(in percent) of Middle income and Emissions(in percent) of Israel?
Keep it short and to the point. 25.13. In the year 1990, what is the difference between the Emissions(in percent) of Middle income and Emissions(in percent) of Sri Lanka?
Your answer should be very brief. 52.96. In the year 1990, what is the difference between the Emissions(in percent) in Greece and Emissions(in percent) in Israel?
Offer a very short reply. 14.81. In the year 1990, what is the difference between the Emissions(in percent) in Greece and Emissions(in percent) in Sri Lanka?
Your answer should be very brief. 42.64. In the year 1990, what is the difference between the Emissions(in percent) of Israel and Emissions(in percent) of Sri Lanka?
Offer a very short reply. 27.83. In the year 1991, what is the difference between the Emissions(in percent) in Middle income and Emissions(in percent) in Greece?
Provide a succinct answer. 11.67. In the year 1991, what is the difference between the Emissions(in percent) of Middle income and Emissions(in percent) of Israel?
Provide a short and direct response. 22.87. In the year 1991, what is the difference between the Emissions(in percent) in Middle income and Emissions(in percent) in Sri Lanka?
Your answer should be compact. 52.78. In the year 1991, what is the difference between the Emissions(in percent) in Greece and Emissions(in percent) in Israel?
Provide a succinct answer. 11.2. In the year 1991, what is the difference between the Emissions(in percent) of Greece and Emissions(in percent) of Sri Lanka?
Give a very brief answer. 41.1. In the year 1991, what is the difference between the Emissions(in percent) of Israel and Emissions(in percent) of Sri Lanka?
Your response must be concise. 29.91. In the year 1992, what is the difference between the Emissions(in percent) of Middle income and Emissions(in percent) of Greece?
Offer a very short reply. 7.29. In the year 1992, what is the difference between the Emissions(in percent) of Middle income and Emissions(in percent) of Israel?
Provide a succinct answer. 18.07. In the year 1992, what is the difference between the Emissions(in percent) in Middle income and Emissions(in percent) in Sri Lanka?
Keep it short and to the point. 49.72. In the year 1992, what is the difference between the Emissions(in percent) of Greece and Emissions(in percent) of Israel?
Your answer should be compact. 10.78. In the year 1992, what is the difference between the Emissions(in percent) of Greece and Emissions(in percent) of Sri Lanka?
Offer a terse response. 42.43. In the year 1992, what is the difference between the Emissions(in percent) in Israel and Emissions(in percent) in Sri Lanka?
Your answer should be compact. 31.66. What is the ratio of the Emissions(in percent) in Middle income in 1983 to that in 1984?
Your answer should be compact. 0.97. What is the ratio of the Emissions(in percent) of Greece in 1983 to that in 1984?
Make the answer very short. 0.96. What is the ratio of the Emissions(in percent) of Israel in 1983 to that in 1984?
Offer a terse response. 0.62. What is the ratio of the Emissions(in percent) in Sri Lanka in 1983 to that in 1984?
Offer a terse response. 8.35. What is the ratio of the Emissions(in percent) of Middle income in 1983 to that in 1985?
Give a very brief answer. 0.95. What is the ratio of the Emissions(in percent) in Greece in 1983 to that in 1985?
Provide a short and direct response. 0.88. What is the ratio of the Emissions(in percent) in Israel in 1983 to that in 1985?
Keep it short and to the point. 0.6. What is the ratio of the Emissions(in percent) of Sri Lanka in 1983 to that in 1985?
Offer a terse response. 8.51. What is the ratio of the Emissions(in percent) in Middle income in 1983 to that in 1986?
Provide a short and direct response. 0.95. What is the ratio of the Emissions(in percent) of Greece in 1983 to that in 1986?
Provide a short and direct response. 0.84. What is the ratio of the Emissions(in percent) of Israel in 1983 to that in 1986?
Keep it short and to the point. 0.58. What is the ratio of the Emissions(in percent) of Sri Lanka in 1983 to that in 1986?
Keep it short and to the point. 15.92. What is the ratio of the Emissions(in percent) of Middle income in 1983 to that in 1989?
Provide a succinct answer. 0.95. What is the ratio of the Emissions(in percent) of Greece in 1983 to that in 1989?
Give a very brief answer. 0.81. What is the ratio of the Emissions(in percent) of Israel in 1983 to that in 1989?
Make the answer very short. 0.64. What is the ratio of the Emissions(in percent) in Sri Lanka in 1983 to that in 1989?
Offer a terse response. 14.98. What is the ratio of the Emissions(in percent) in Middle income in 1983 to that in 1990?
Your response must be concise. 0.95. What is the ratio of the Emissions(in percent) of Greece in 1983 to that in 1990?
Your answer should be compact. 0.81. What is the ratio of the Emissions(in percent) of Israel in 1983 to that in 1990?
Make the answer very short. 0.67. What is the ratio of the Emissions(in percent) of Sri Lanka in 1983 to that in 1990?
Give a very brief answer. 16.63. What is the ratio of the Emissions(in percent) of Middle income in 1983 to that in 1991?
Give a very brief answer. 0.95. What is the ratio of the Emissions(in percent) of Greece in 1983 to that in 1991?
Offer a very short reply. 0.84. What is the ratio of the Emissions(in percent) in Israel in 1983 to that in 1991?
Provide a succinct answer. 0.62. What is the ratio of the Emissions(in percent) of Sri Lanka in 1983 to that in 1991?
Offer a terse response. 8.98. What is the ratio of the Emissions(in percent) in Greece in 1983 to that in 1992?
Keep it short and to the point. 0.81. What is the ratio of the Emissions(in percent) of Israel in 1983 to that in 1992?
Provide a short and direct response. 0.59. What is the ratio of the Emissions(in percent) of Sri Lanka in 1983 to that in 1992?
Ensure brevity in your answer.  22.29. What is the ratio of the Emissions(in percent) of Middle income in 1984 to that in 1985?
Give a very brief answer. 0.98. What is the ratio of the Emissions(in percent) of Greece in 1984 to that in 1985?
Your response must be concise. 0.92. What is the ratio of the Emissions(in percent) of Israel in 1984 to that in 1985?
Your answer should be very brief. 0.96. What is the ratio of the Emissions(in percent) in Sri Lanka in 1984 to that in 1985?
Ensure brevity in your answer.  1.02. What is the ratio of the Emissions(in percent) of Middle income in 1984 to that in 1986?
Your response must be concise. 0.98. What is the ratio of the Emissions(in percent) in Greece in 1984 to that in 1986?
Ensure brevity in your answer.  0.88. What is the ratio of the Emissions(in percent) in Israel in 1984 to that in 1986?
Provide a succinct answer. 0.94. What is the ratio of the Emissions(in percent) in Sri Lanka in 1984 to that in 1986?
Offer a terse response. 1.91. What is the ratio of the Emissions(in percent) in Middle income in 1984 to that in 1989?
Make the answer very short. 0.98. What is the ratio of the Emissions(in percent) of Greece in 1984 to that in 1989?
Keep it short and to the point. 0.85. What is the ratio of the Emissions(in percent) of Israel in 1984 to that in 1989?
Provide a short and direct response. 1.03. What is the ratio of the Emissions(in percent) of Sri Lanka in 1984 to that in 1989?
Make the answer very short. 1.79. What is the ratio of the Emissions(in percent) in Middle income in 1984 to that in 1990?
Ensure brevity in your answer.  0.97. What is the ratio of the Emissions(in percent) in Greece in 1984 to that in 1990?
Make the answer very short. 0.85. What is the ratio of the Emissions(in percent) of Israel in 1984 to that in 1990?
Make the answer very short. 1.07. What is the ratio of the Emissions(in percent) of Sri Lanka in 1984 to that in 1990?
Keep it short and to the point. 1.99. What is the ratio of the Emissions(in percent) in Middle income in 1984 to that in 1991?
Your answer should be compact. 0.97. What is the ratio of the Emissions(in percent) of Greece in 1984 to that in 1991?
Offer a very short reply. 0.88. What is the ratio of the Emissions(in percent) of Sri Lanka in 1984 to that in 1991?
Your answer should be very brief. 1.08. What is the ratio of the Emissions(in percent) in Middle income in 1984 to that in 1992?
Your answer should be compact. 1.03. What is the ratio of the Emissions(in percent) in Greece in 1984 to that in 1992?
Your answer should be very brief. 0.85. What is the ratio of the Emissions(in percent) of Israel in 1984 to that in 1992?
Offer a very short reply. 0.95. What is the ratio of the Emissions(in percent) of Sri Lanka in 1984 to that in 1992?
Make the answer very short. 2.67. What is the ratio of the Emissions(in percent) of Middle income in 1985 to that in 1986?
Make the answer very short. 1. What is the ratio of the Emissions(in percent) in Greece in 1985 to that in 1986?
Provide a succinct answer. 0.95. What is the ratio of the Emissions(in percent) of Israel in 1985 to that in 1986?
Your answer should be compact. 0.98. What is the ratio of the Emissions(in percent) in Sri Lanka in 1985 to that in 1986?
Your response must be concise. 1.87. What is the ratio of the Emissions(in percent) of Middle income in 1985 to that in 1989?
Your answer should be compact. 1. What is the ratio of the Emissions(in percent) of Greece in 1985 to that in 1989?
Offer a very short reply. 0.93. What is the ratio of the Emissions(in percent) in Israel in 1985 to that in 1989?
Your answer should be very brief. 1.08. What is the ratio of the Emissions(in percent) of Sri Lanka in 1985 to that in 1989?
Provide a succinct answer. 1.76. What is the ratio of the Emissions(in percent) in Middle income in 1985 to that in 1990?
Offer a terse response. 0.99. What is the ratio of the Emissions(in percent) of Greece in 1985 to that in 1990?
Keep it short and to the point. 0.92. What is the ratio of the Emissions(in percent) of Israel in 1985 to that in 1990?
Offer a terse response. 1.12. What is the ratio of the Emissions(in percent) of Sri Lanka in 1985 to that in 1990?
Offer a terse response. 1.96. What is the ratio of the Emissions(in percent) in Middle income in 1985 to that in 1991?
Your answer should be very brief. 1. What is the ratio of the Emissions(in percent) of Greece in 1985 to that in 1991?
Your response must be concise. 0.95. What is the ratio of the Emissions(in percent) of Israel in 1985 to that in 1991?
Give a very brief answer. 1.04. What is the ratio of the Emissions(in percent) in Sri Lanka in 1985 to that in 1991?
Make the answer very short. 1.06. What is the ratio of the Emissions(in percent) of Middle income in 1985 to that in 1992?
Ensure brevity in your answer.  1.06. What is the ratio of the Emissions(in percent) in Greece in 1985 to that in 1992?
Your response must be concise. 0.92. What is the ratio of the Emissions(in percent) of Israel in 1985 to that in 1992?
Offer a very short reply. 0.99. What is the ratio of the Emissions(in percent) of Sri Lanka in 1985 to that in 1992?
Offer a very short reply. 2.62. What is the ratio of the Emissions(in percent) of Greece in 1986 to that in 1989?
Offer a very short reply. 0.97. What is the ratio of the Emissions(in percent) in Israel in 1986 to that in 1989?
Provide a succinct answer. 1.11. What is the ratio of the Emissions(in percent) in Sri Lanka in 1986 to that in 1989?
Offer a very short reply. 0.94. What is the ratio of the Emissions(in percent) in Middle income in 1986 to that in 1990?
Ensure brevity in your answer.  1. What is the ratio of the Emissions(in percent) in Greece in 1986 to that in 1990?
Offer a terse response. 0.96. What is the ratio of the Emissions(in percent) in Israel in 1986 to that in 1990?
Offer a terse response. 1.15. What is the ratio of the Emissions(in percent) of Sri Lanka in 1986 to that in 1990?
Your answer should be compact. 1.04. What is the ratio of the Emissions(in percent) of Israel in 1986 to that in 1991?
Make the answer very short. 1.07. What is the ratio of the Emissions(in percent) in Sri Lanka in 1986 to that in 1991?
Provide a succinct answer. 0.56. What is the ratio of the Emissions(in percent) in Middle income in 1986 to that in 1992?
Provide a short and direct response. 1.06. What is the ratio of the Emissions(in percent) in Greece in 1986 to that in 1992?
Offer a very short reply. 0.97. What is the ratio of the Emissions(in percent) in Israel in 1986 to that in 1992?
Offer a very short reply. 1.01. What is the ratio of the Emissions(in percent) in Sri Lanka in 1986 to that in 1992?
Ensure brevity in your answer.  1.4. What is the ratio of the Emissions(in percent) in Middle income in 1989 to that in 1990?
Give a very brief answer. 0.99. What is the ratio of the Emissions(in percent) in Greece in 1989 to that in 1990?
Provide a succinct answer. 0.99. What is the ratio of the Emissions(in percent) of Israel in 1989 to that in 1990?
Offer a terse response. 1.04. What is the ratio of the Emissions(in percent) of Sri Lanka in 1989 to that in 1990?
Give a very brief answer. 1.11. What is the ratio of the Emissions(in percent) of Middle income in 1989 to that in 1991?
Your answer should be compact. 0.99. What is the ratio of the Emissions(in percent) in Greece in 1989 to that in 1991?
Give a very brief answer. 1.03. What is the ratio of the Emissions(in percent) of Israel in 1989 to that in 1991?
Offer a terse response. 0.96. What is the ratio of the Emissions(in percent) in Sri Lanka in 1989 to that in 1991?
Keep it short and to the point. 0.6. What is the ratio of the Emissions(in percent) of Middle income in 1989 to that in 1992?
Your answer should be compact. 1.06. What is the ratio of the Emissions(in percent) in Greece in 1989 to that in 1992?
Ensure brevity in your answer.  1. What is the ratio of the Emissions(in percent) in Israel in 1989 to that in 1992?
Keep it short and to the point. 0.91. What is the ratio of the Emissions(in percent) in Sri Lanka in 1989 to that in 1992?
Offer a terse response. 1.49. What is the ratio of the Emissions(in percent) in Greece in 1990 to that in 1991?
Offer a very short reply. 1.04. What is the ratio of the Emissions(in percent) of Israel in 1990 to that in 1991?
Offer a terse response. 0.93. What is the ratio of the Emissions(in percent) of Sri Lanka in 1990 to that in 1991?
Provide a succinct answer. 0.54. What is the ratio of the Emissions(in percent) in Middle income in 1990 to that in 1992?
Offer a very short reply. 1.07. What is the ratio of the Emissions(in percent) of Greece in 1990 to that in 1992?
Ensure brevity in your answer.  1.01. What is the ratio of the Emissions(in percent) in Sri Lanka in 1990 to that in 1992?
Your answer should be very brief. 1.34. What is the ratio of the Emissions(in percent) in Middle income in 1991 to that in 1992?
Keep it short and to the point. 1.06. What is the ratio of the Emissions(in percent) in Greece in 1991 to that in 1992?
Your response must be concise. 0.97. What is the ratio of the Emissions(in percent) in Israel in 1991 to that in 1992?
Give a very brief answer. 0.95. What is the ratio of the Emissions(in percent) in Sri Lanka in 1991 to that in 1992?
Make the answer very short. 2.48. What is the difference between the highest and the second highest Emissions(in percent) in Middle income?
Ensure brevity in your answer.  0.1. What is the difference between the highest and the second highest Emissions(in percent) in Greece?
Provide a short and direct response. 0.23. What is the difference between the highest and the second highest Emissions(in percent) of Israel?
Give a very brief answer. 0.36. What is the difference between the highest and the second highest Emissions(in percent) in Sri Lanka?
Offer a very short reply. 1.39. What is the difference between the highest and the lowest Emissions(in percent) in Middle income?
Your answer should be compact. 3.26. What is the difference between the highest and the lowest Emissions(in percent) of Greece?
Your answer should be very brief. 8.2. What is the difference between the highest and the lowest Emissions(in percent) of Israel?
Provide a succinct answer. 13.4. What is the difference between the highest and the lowest Emissions(in percent) of Sri Lanka?
Ensure brevity in your answer.  1.51. 